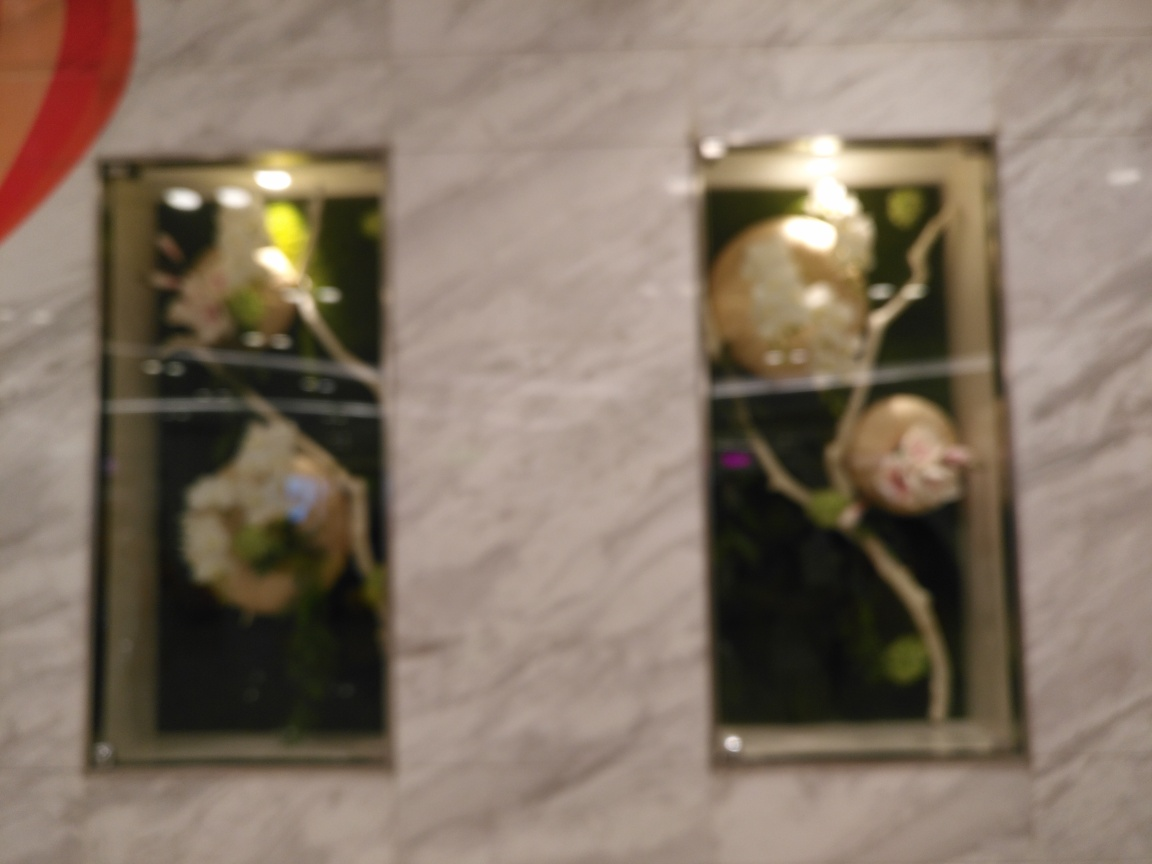Is the background slightly out of focus? Yes, the image shows that both the foreground and the background are out of focus. This lack of focus spans across the entire image, affecting the clarity of the subjects within both the frames on the wall and the wall itself. 